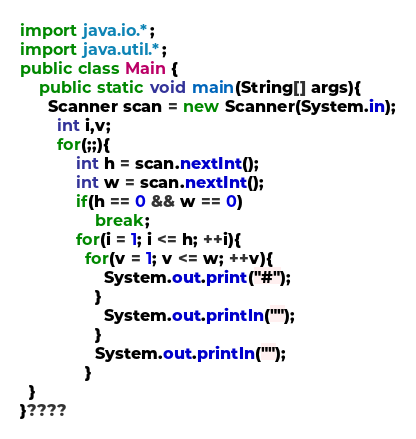<code> <loc_0><loc_0><loc_500><loc_500><_Java_>import java.io.*;
import java.util.*;
public class Main {
    public static void main(String[] args){
      Scanner scan = new Scanner(System.in);
        int i,v;
        for(;;){
            int h = scan.nextInt();
            int w = scan.nextInt();
            if(h == 0 && w == 0)
                break;
            for(i = 1; i <= h; ++i){
              for(v = 1; v <= w; ++v){
                  System.out.print("#");
                }
                  System.out.println("");
                }
                System.out.println("");
              }
  }
}???? </code> 